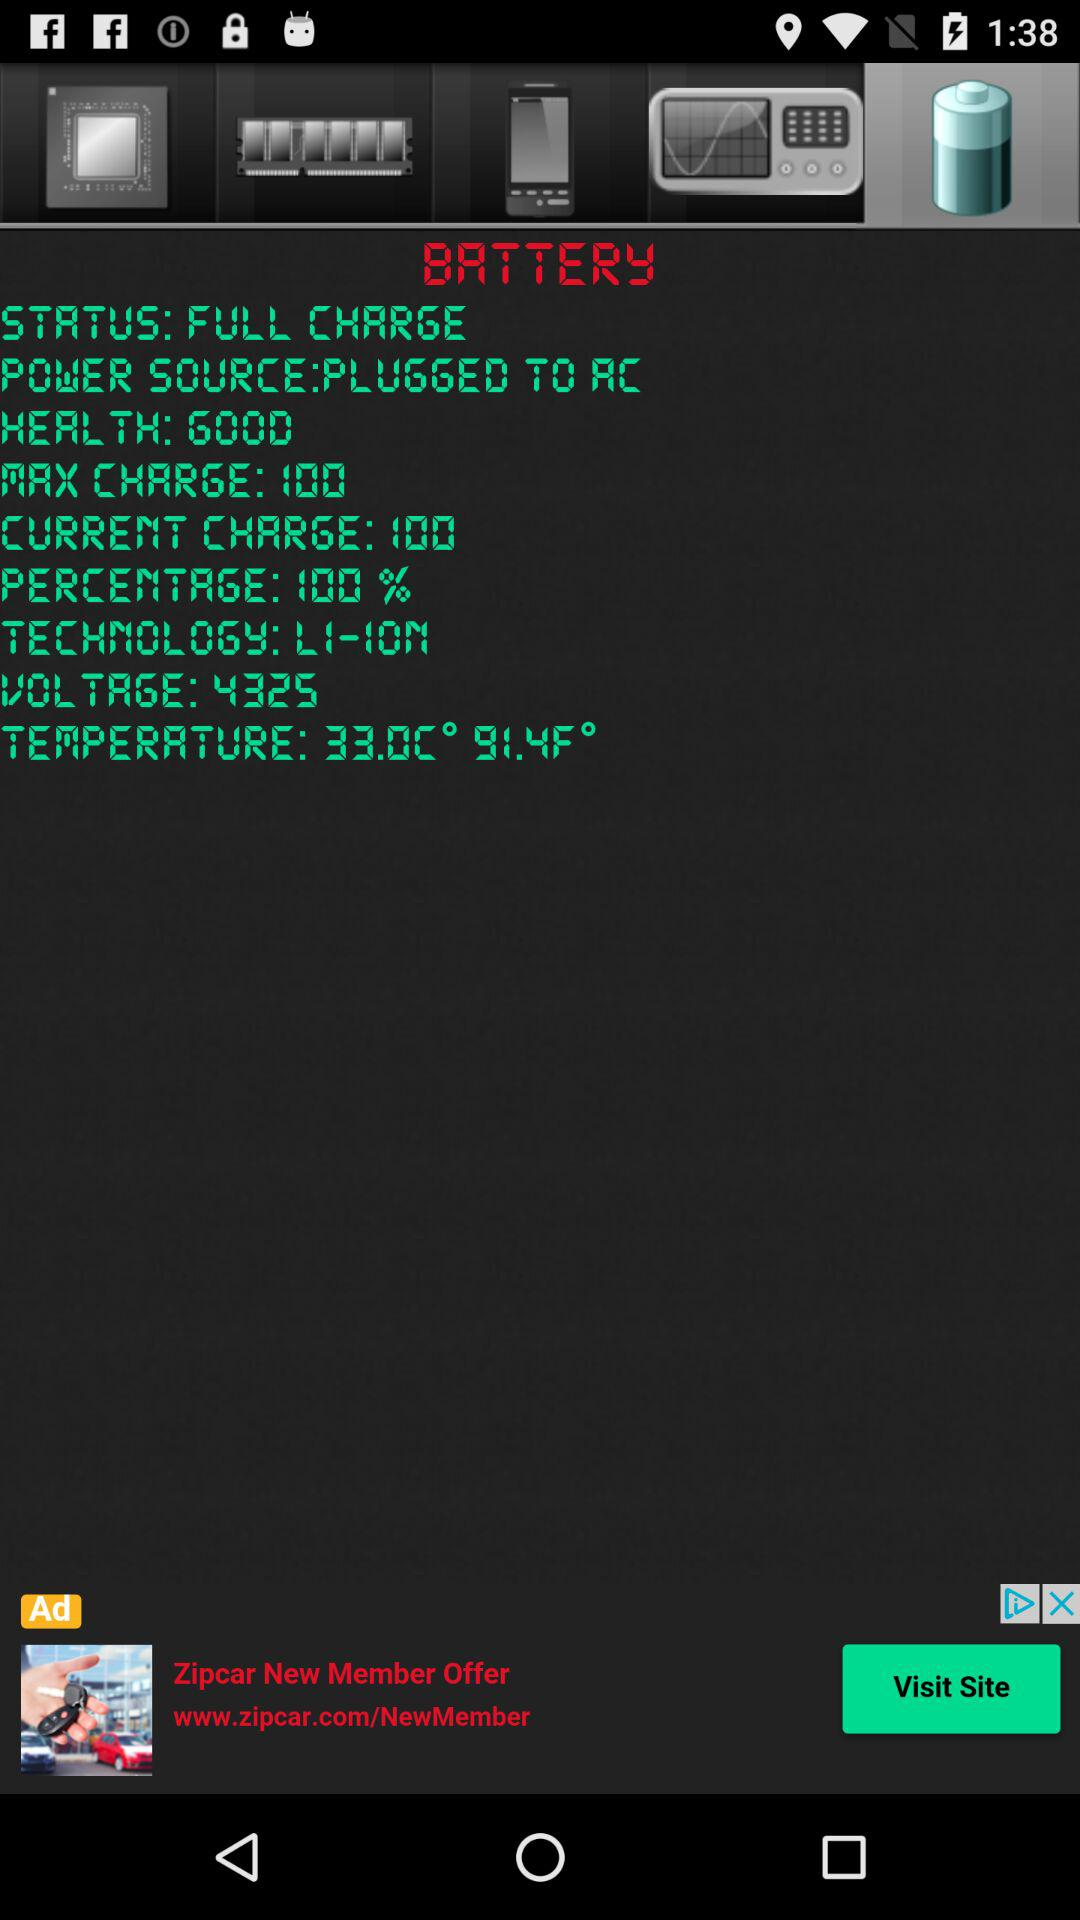What is the battery percentage? The battery percentage is 100. 